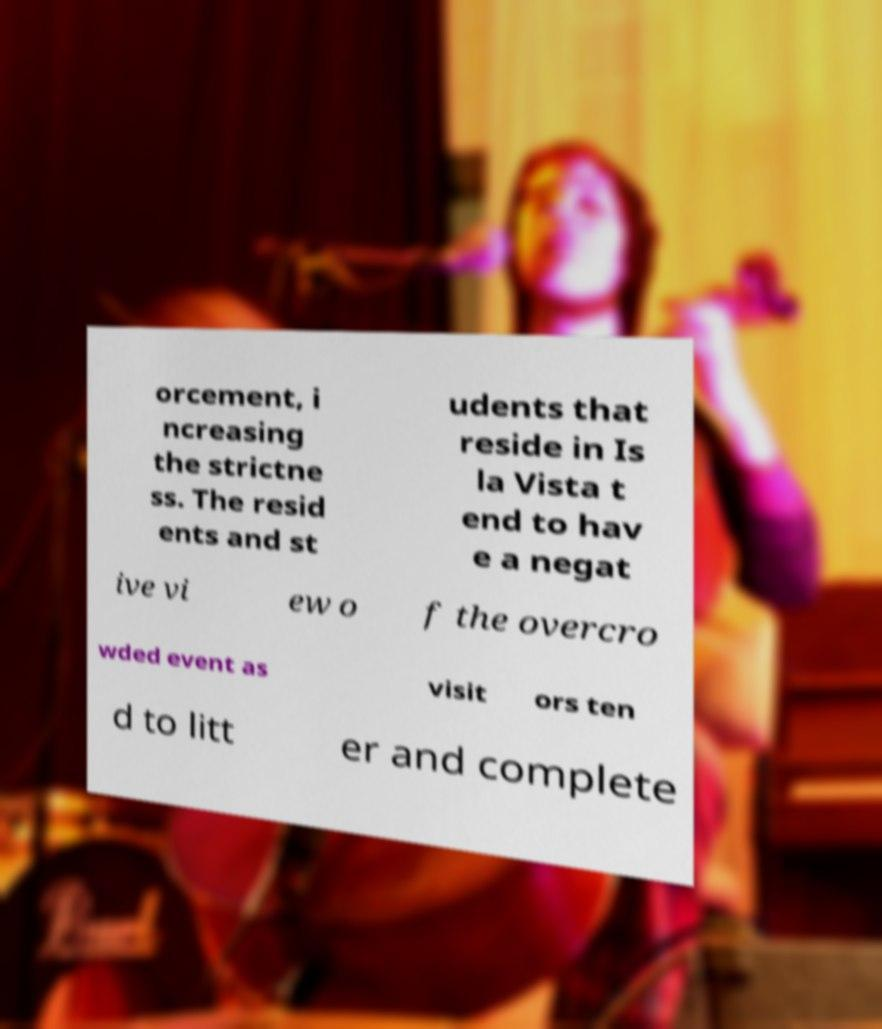Can you read and provide the text displayed in the image?This photo seems to have some interesting text. Can you extract and type it out for me? orcement, i ncreasing the strictne ss. The resid ents and st udents that reside in Is la Vista t end to hav e a negat ive vi ew o f the overcro wded event as visit ors ten d to litt er and complete 